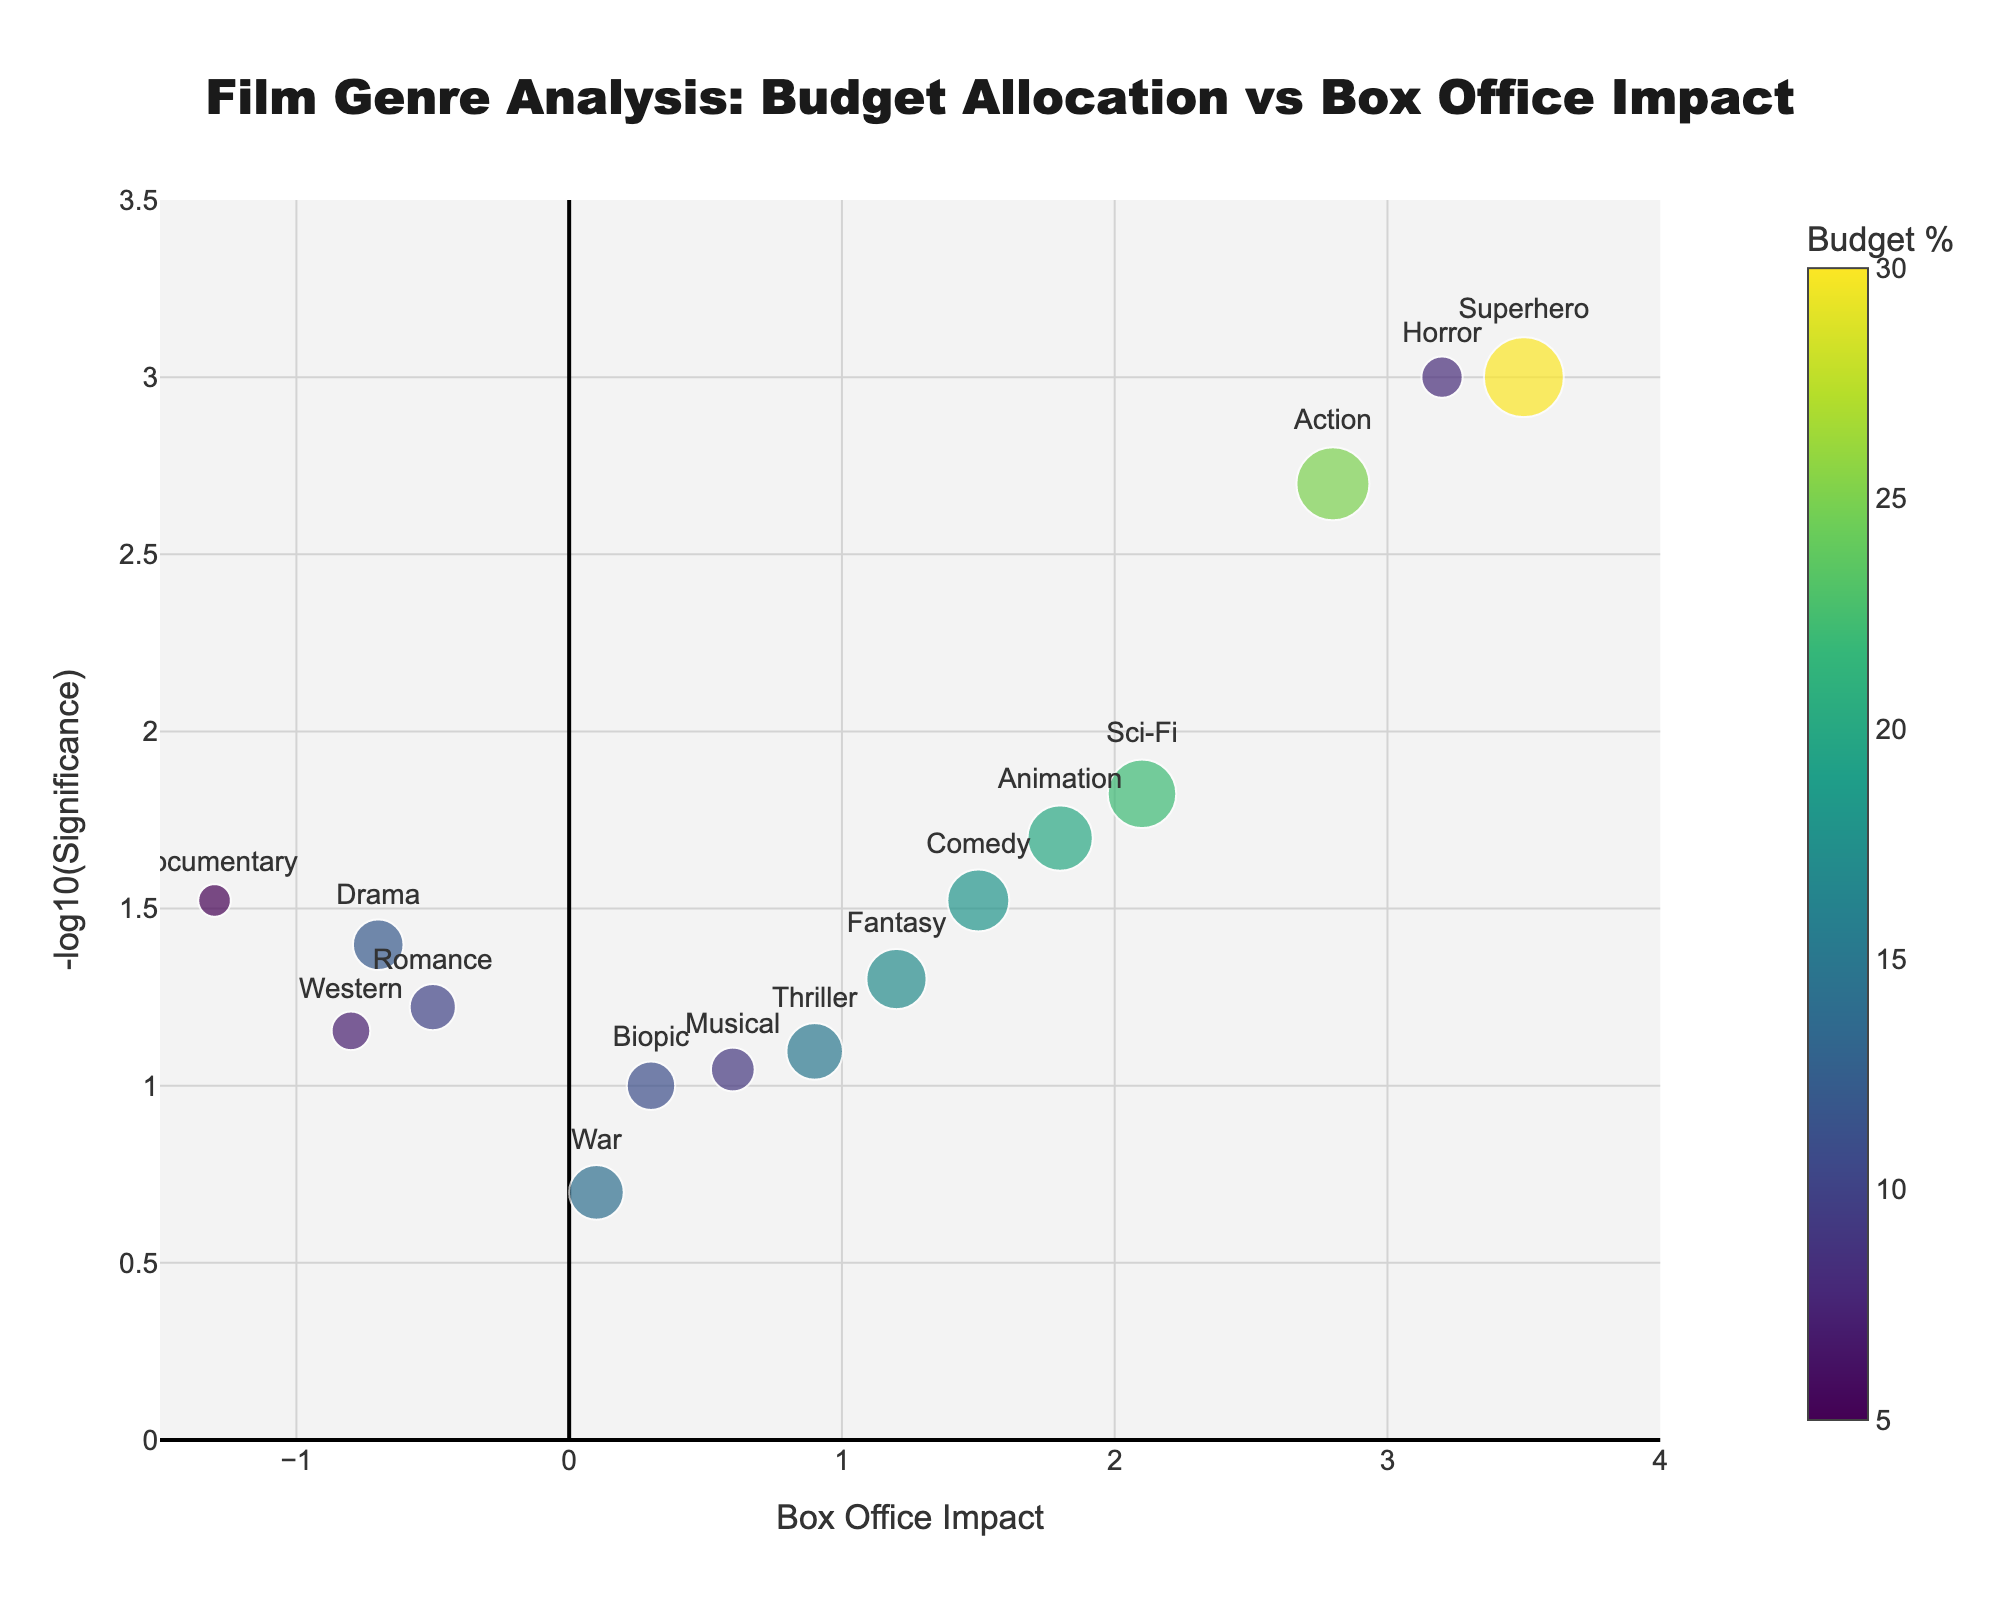Which genre has the highest significance value? The highest significance value can be determined by looking at the -log10(Significance) on the y-axis. The genre with the highest -log10(Significance) is "Superhero," which is located at the top of the plot.
Answer: Superhero Which genre has the highest budget percentage? The highest budget percentage can be identified by the size of the markers, with larger markers representing higher budget percentages. The largest marker represents the "Superhero" genre, which has a budget percentage of 30%.
Answer: Superhero How does the significance of the Action genre compare to that of the Horror genre? To compare the significance, we can look at the y-axis values (-log10(Significance)). The Action genre has a significance value shown as 2.8, and the Horror genre has a value displayed slightly above 3. Since the Horror genre has a higher -log10(Significance), it is more significant than the Action genre.
Answer: Horror is more significant than Action Among Comedy, Drama, and Documentary, which genre has the highest box office impact? The box office impact can be determined by the x-axis values. Checking Comedy (1.5), Drama (-0.7), and Documentary (-1.3), Comedy has the highest box office impact (1.5).
Answer: Comedy What is the relationship between budget percentage and box office impact for the Sci-Fi genre? The budget percentage for Sci-Fi is represented by the marker size, which is 22%. The box office impact can be found on the x-axis, where it is marked as 2.1.
Answer: Budget percentage: 22%, Box office impact: 2.1 What is the box office impact of genres with a significance value lower than 0.01? By looking at the y-axis (-log10(Significance)), a significance value of 0.01 corresponds to -log10(0.01) = 2. Only the genres above this threshold are considered. The genres that satisfy this condition are “Horror” and “Superhero,” with box office impacts of 3.2 and 3.5, respectively.
Answer: Horror: 3.2, Superhero: 3.5 Compare the box office impact of Animation and Romance genres and state which one performs better. The box office impact can be found on the x-axis for both genres. Animation has an impact of 1.8, while Romance has an impact of -0.5. Animation has a higher box office impact than Romance.
Answer: Animation What overall trend can you observe regarding the significance of film genres with negative box office impacts? Negative box office impacts are to the left of the x-axis (less than 0). The genres with negative impacts (Drama, Romance, Documentary, Western) generally show lower significance values, which is indicated by their lower positions on the y-axis.
Answer: Lower significance Identify and compare the significance values of the genres with the top two highest budget percentages. The top two highest budget percentages are Superhero (30%) and Action (25%). The significance values, represented by -log10(Significance) on the y-axis, are 3.5 for Superhero and 2.8 for Action.
Answer: Superhero: 3.5, Action: 2.8 